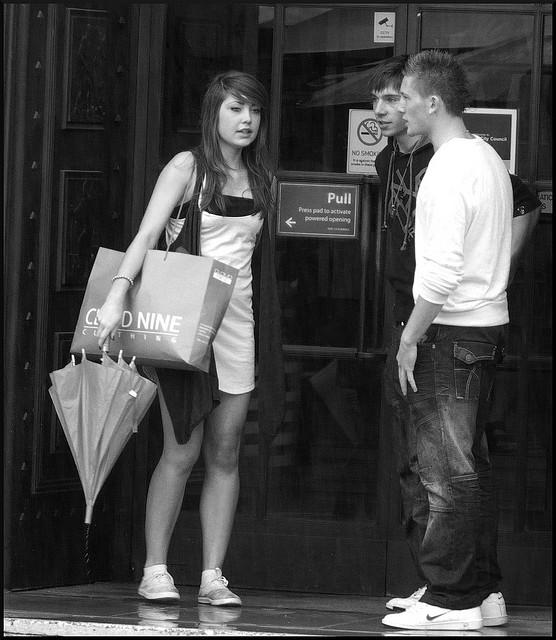What are the boys doing? Please explain your reasoning. being friendly. They are young people talking to an attractive woman, and it is obvious by the body language that they are interested in her. 